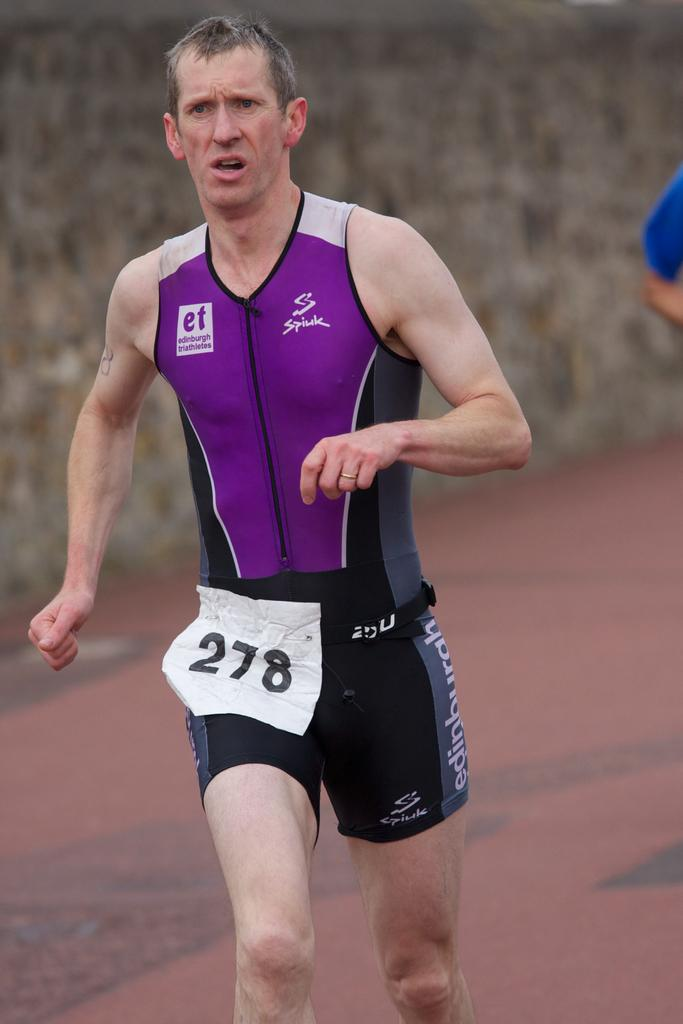Provide a one-sentence caption for the provided image. 1 men running on the track with the numbers 278. 